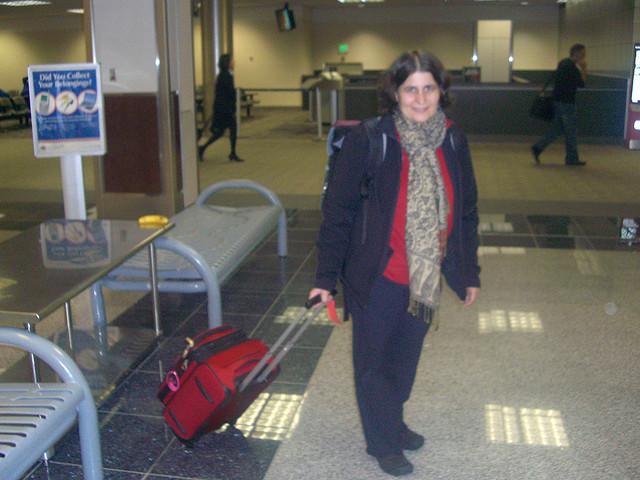What is she pulling?
Give a very brief answer. Luggage. Is the type of jacket the woman is wearing likely to get dirty easily?
Be succinct. No. What word is on the wall behind the woman?
Give a very brief answer. Exit. Is there a TSA sign in this image?
Answer briefly. Yes. Is the woman traveling?
Write a very short answer. Yes. 